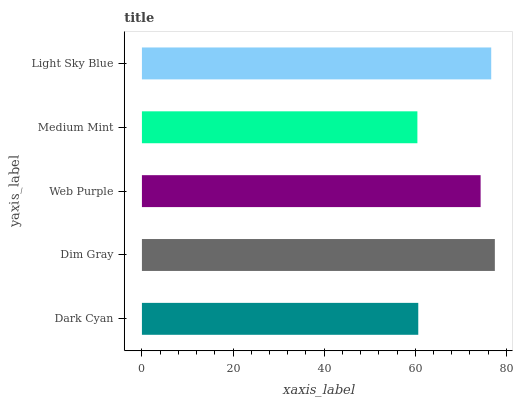Is Medium Mint the minimum?
Answer yes or no. Yes. Is Dim Gray the maximum?
Answer yes or no. Yes. Is Web Purple the minimum?
Answer yes or no. No. Is Web Purple the maximum?
Answer yes or no. No. Is Dim Gray greater than Web Purple?
Answer yes or no. Yes. Is Web Purple less than Dim Gray?
Answer yes or no. Yes. Is Web Purple greater than Dim Gray?
Answer yes or no. No. Is Dim Gray less than Web Purple?
Answer yes or no. No. Is Web Purple the high median?
Answer yes or no. Yes. Is Web Purple the low median?
Answer yes or no. Yes. Is Light Sky Blue the high median?
Answer yes or no. No. Is Light Sky Blue the low median?
Answer yes or no. No. 